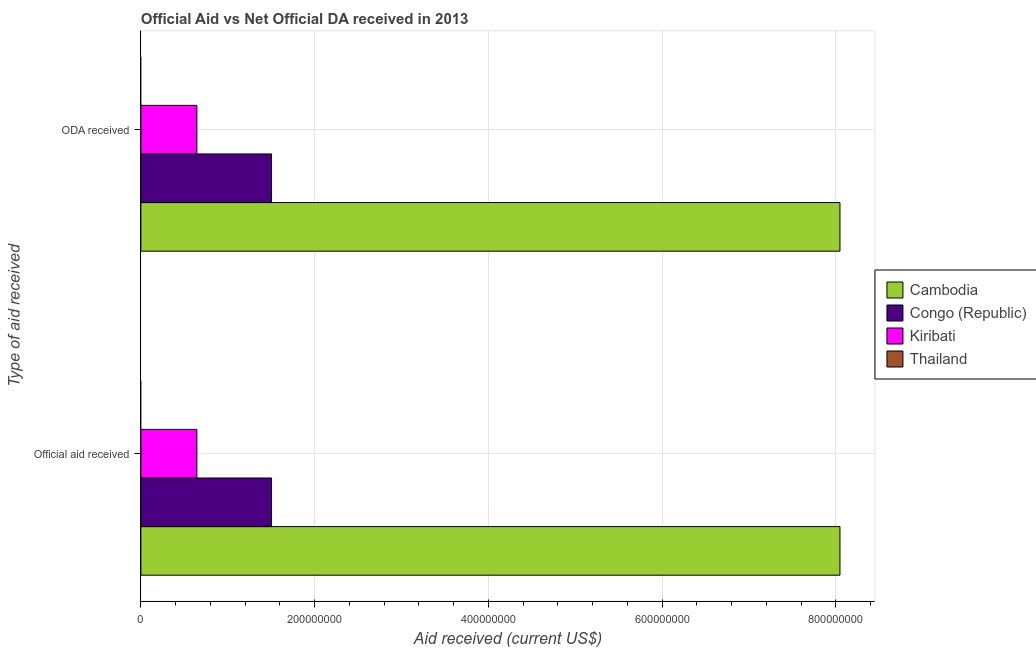How many different coloured bars are there?
Keep it short and to the point. 3. How many groups of bars are there?
Provide a short and direct response. 2. Are the number of bars per tick equal to the number of legend labels?
Provide a succinct answer. No. What is the label of the 2nd group of bars from the top?
Make the answer very short. Official aid received. What is the official aid received in Cambodia?
Provide a short and direct response. 8.05e+08. Across all countries, what is the maximum official aid received?
Provide a succinct answer. 8.05e+08. In which country was the oda received maximum?
Provide a short and direct response. Cambodia. What is the total oda received in the graph?
Your response must be concise. 1.02e+09. What is the difference between the official aid received in Cambodia and that in Kiribati?
Give a very brief answer. 7.40e+08. What is the difference between the official aid received in Congo (Republic) and the oda received in Thailand?
Ensure brevity in your answer.  1.50e+08. What is the average official aid received per country?
Keep it short and to the point. 2.55e+08. What is the ratio of the oda received in Kiribati to that in Congo (Republic)?
Your answer should be compact. 0.43. Is the official aid received in Kiribati less than that in Congo (Republic)?
Your answer should be compact. Yes. Where does the legend appear in the graph?
Offer a terse response. Center right. How are the legend labels stacked?
Give a very brief answer. Vertical. What is the title of the graph?
Your answer should be compact. Official Aid vs Net Official DA received in 2013 . What is the label or title of the X-axis?
Make the answer very short. Aid received (current US$). What is the label or title of the Y-axis?
Provide a short and direct response. Type of aid received. What is the Aid received (current US$) of Cambodia in Official aid received?
Your answer should be very brief. 8.05e+08. What is the Aid received (current US$) of Congo (Republic) in Official aid received?
Provide a succinct answer. 1.50e+08. What is the Aid received (current US$) in Kiribati in Official aid received?
Your answer should be compact. 6.44e+07. What is the Aid received (current US$) of Thailand in Official aid received?
Offer a very short reply. 0. What is the Aid received (current US$) in Cambodia in ODA received?
Your answer should be compact. 8.05e+08. What is the Aid received (current US$) in Congo (Republic) in ODA received?
Your response must be concise. 1.50e+08. What is the Aid received (current US$) in Kiribati in ODA received?
Offer a very short reply. 6.44e+07. Across all Type of aid received, what is the maximum Aid received (current US$) of Cambodia?
Provide a short and direct response. 8.05e+08. Across all Type of aid received, what is the maximum Aid received (current US$) in Congo (Republic)?
Your response must be concise. 1.50e+08. Across all Type of aid received, what is the maximum Aid received (current US$) in Kiribati?
Provide a short and direct response. 6.44e+07. Across all Type of aid received, what is the minimum Aid received (current US$) of Cambodia?
Your answer should be compact. 8.05e+08. Across all Type of aid received, what is the minimum Aid received (current US$) in Congo (Republic)?
Offer a very short reply. 1.50e+08. Across all Type of aid received, what is the minimum Aid received (current US$) of Kiribati?
Keep it short and to the point. 6.44e+07. What is the total Aid received (current US$) in Cambodia in the graph?
Provide a succinct answer. 1.61e+09. What is the total Aid received (current US$) of Congo (Republic) in the graph?
Provide a succinct answer. 3.01e+08. What is the total Aid received (current US$) in Kiribati in the graph?
Your answer should be very brief. 1.29e+08. What is the total Aid received (current US$) in Thailand in the graph?
Make the answer very short. 0. What is the difference between the Aid received (current US$) in Cambodia in Official aid received and that in ODA received?
Make the answer very short. 0. What is the difference between the Aid received (current US$) in Congo (Republic) in Official aid received and that in ODA received?
Provide a succinct answer. 0. What is the difference between the Aid received (current US$) in Cambodia in Official aid received and the Aid received (current US$) in Congo (Republic) in ODA received?
Ensure brevity in your answer.  6.54e+08. What is the difference between the Aid received (current US$) in Cambodia in Official aid received and the Aid received (current US$) in Kiribati in ODA received?
Make the answer very short. 7.40e+08. What is the difference between the Aid received (current US$) of Congo (Republic) in Official aid received and the Aid received (current US$) of Kiribati in ODA received?
Offer a very short reply. 8.60e+07. What is the average Aid received (current US$) of Cambodia per Type of aid received?
Keep it short and to the point. 8.05e+08. What is the average Aid received (current US$) in Congo (Republic) per Type of aid received?
Provide a short and direct response. 1.50e+08. What is the average Aid received (current US$) in Kiribati per Type of aid received?
Your response must be concise. 6.44e+07. What is the difference between the Aid received (current US$) in Cambodia and Aid received (current US$) in Congo (Republic) in Official aid received?
Keep it short and to the point. 6.54e+08. What is the difference between the Aid received (current US$) in Cambodia and Aid received (current US$) in Kiribati in Official aid received?
Offer a terse response. 7.40e+08. What is the difference between the Aid received (current US$) of Congo (Republic) and Aid received (current US$) of Kiribati in Official aid received?
Your answer should be very brief. 8.60e+07. What is the difference between the Aid received (current US$) in Cambodia and Aid received (current US$) in Congo (Republic) in ODA received?
Make the answer very short. 6.54e+08. What is the difference between the Aid received (current US$) of Cambodia and Aid received (current US$) of Kiribati in ODA received?
Your answer should be very brief. 7.40e+08. What is the difference between the Aid received (current US$) in Congo (Republic) and Aid received (current US$) in Kiribati in ODA received?
Give a very brief answer. 8.60e+07. What is the ratio of the Aid received (current US$) in Cambodia in Official aid received to that in ODA received?
Make the answer very short. 1. What is the ratio of the Aid received (current US$) in Kiribati in Official aid received to that in ODA received?
Give a very brief answer. 1. What is the difference between the highest and the lowest Aid received (current US$) in Congo (Republic)?
Your response must be concise. 0. 